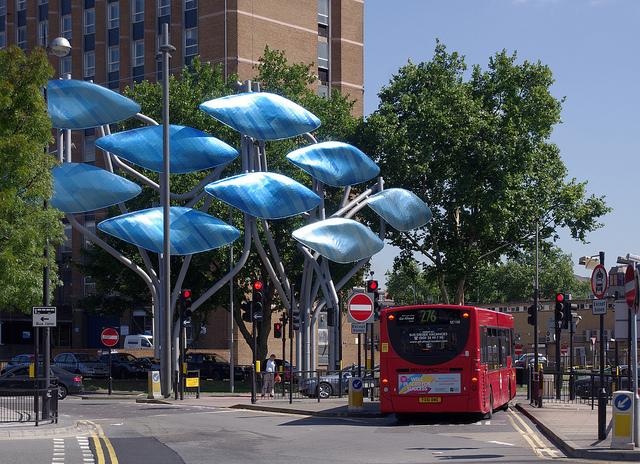Is it cloudy?
Quick response, please. No. Do the two white arrows on blue point in different directions?
Keep it brief. No. What color is the traffic light?
Answer briefly. Red. 